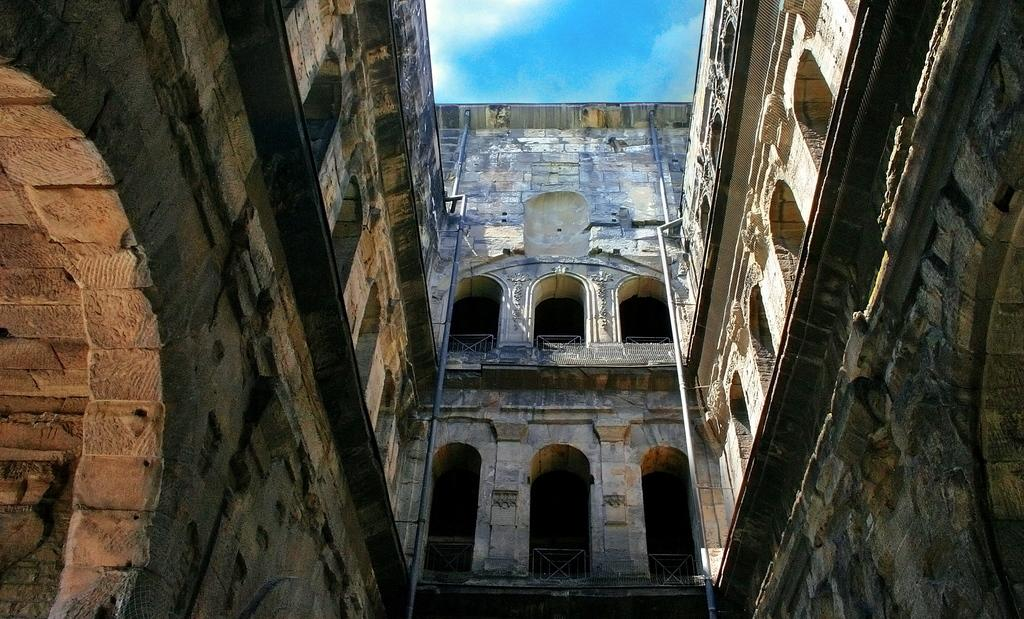What type of structure is present in the image? There is a building in the image. What else can be seen in the image besides the building? There are pipes visible in the image. What is the color of the sky in the image? The sky is blue in color. Are there any weather conditions visible in the image? Yes, there are clouds visible in the image. Can you tell me how many uncles are standing near the building in the image? There is no mention of an uncle or any people in the image; it only shows a building, pipes, and the sky. What type of sponge is being used to clean the pipes in the image? There is no sponge or cleaning activity depicted in the image; it only shows a building and pipes. 